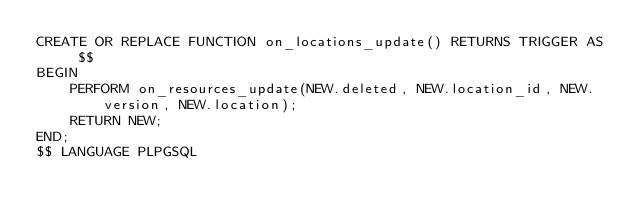<code> <loc_0><loc_0><loc_500><loc_500><_SQL_>CREATE OR REPLACE FUNCTION on_locations_update() RETURNS TRIGGER AS $$
BEGIN
	PERFORM on_resources_update(NEW.deleted, NEW.location_id, NEW.version, NEW.location);
	RETURN NEW;
END;
$$ LANGUAGE PLPGSQL</code> 